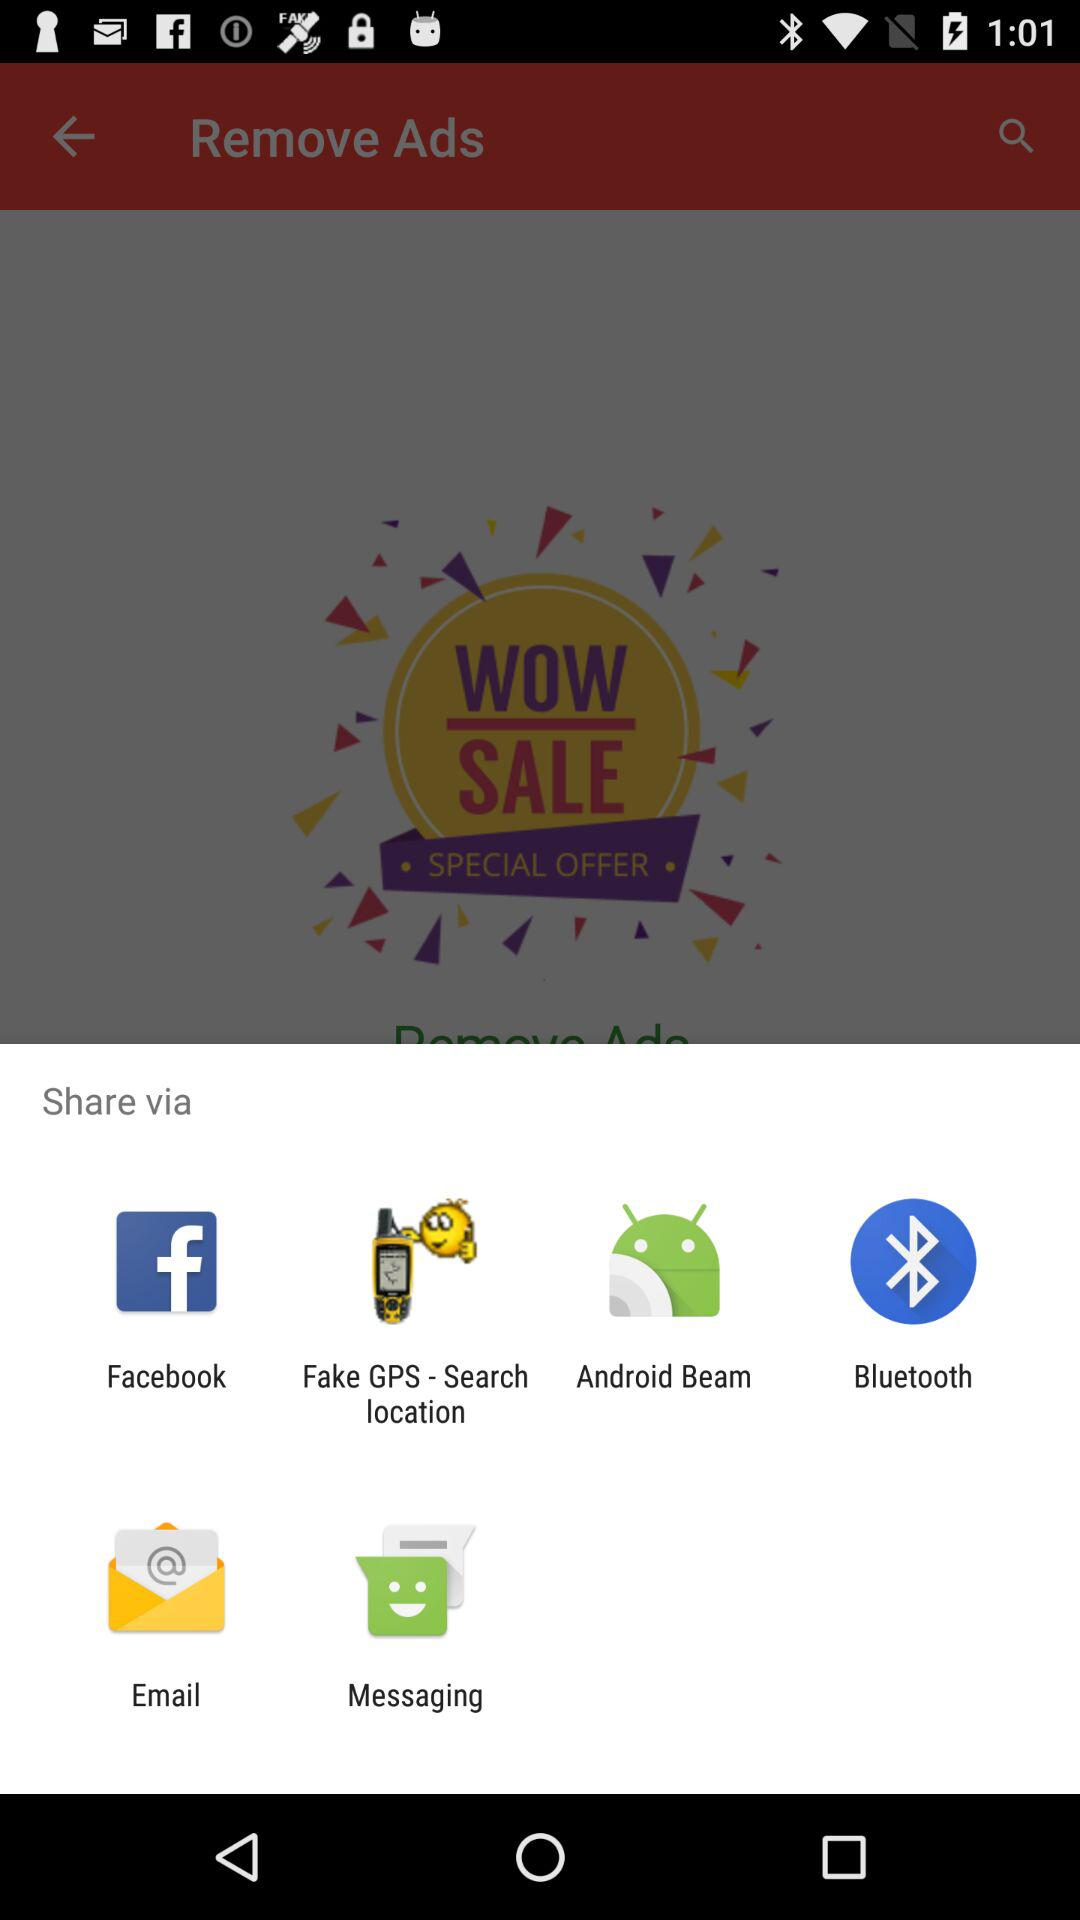How much does it cost to remove ads?
When the provided information is insufficient, respond with <no answer>. <no answer> 